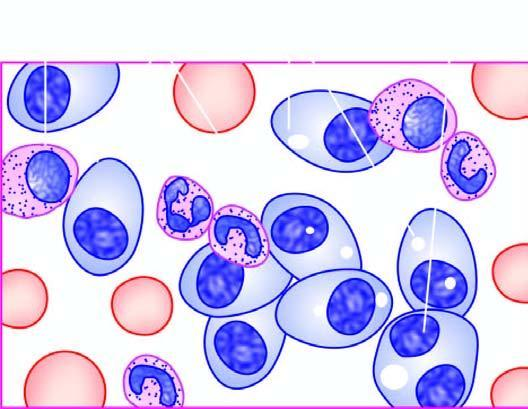does one marrow aspirate in myeloma show numerous plasma cells, many with abnormal features?
Answer the question using a single word or phrase. Yes 